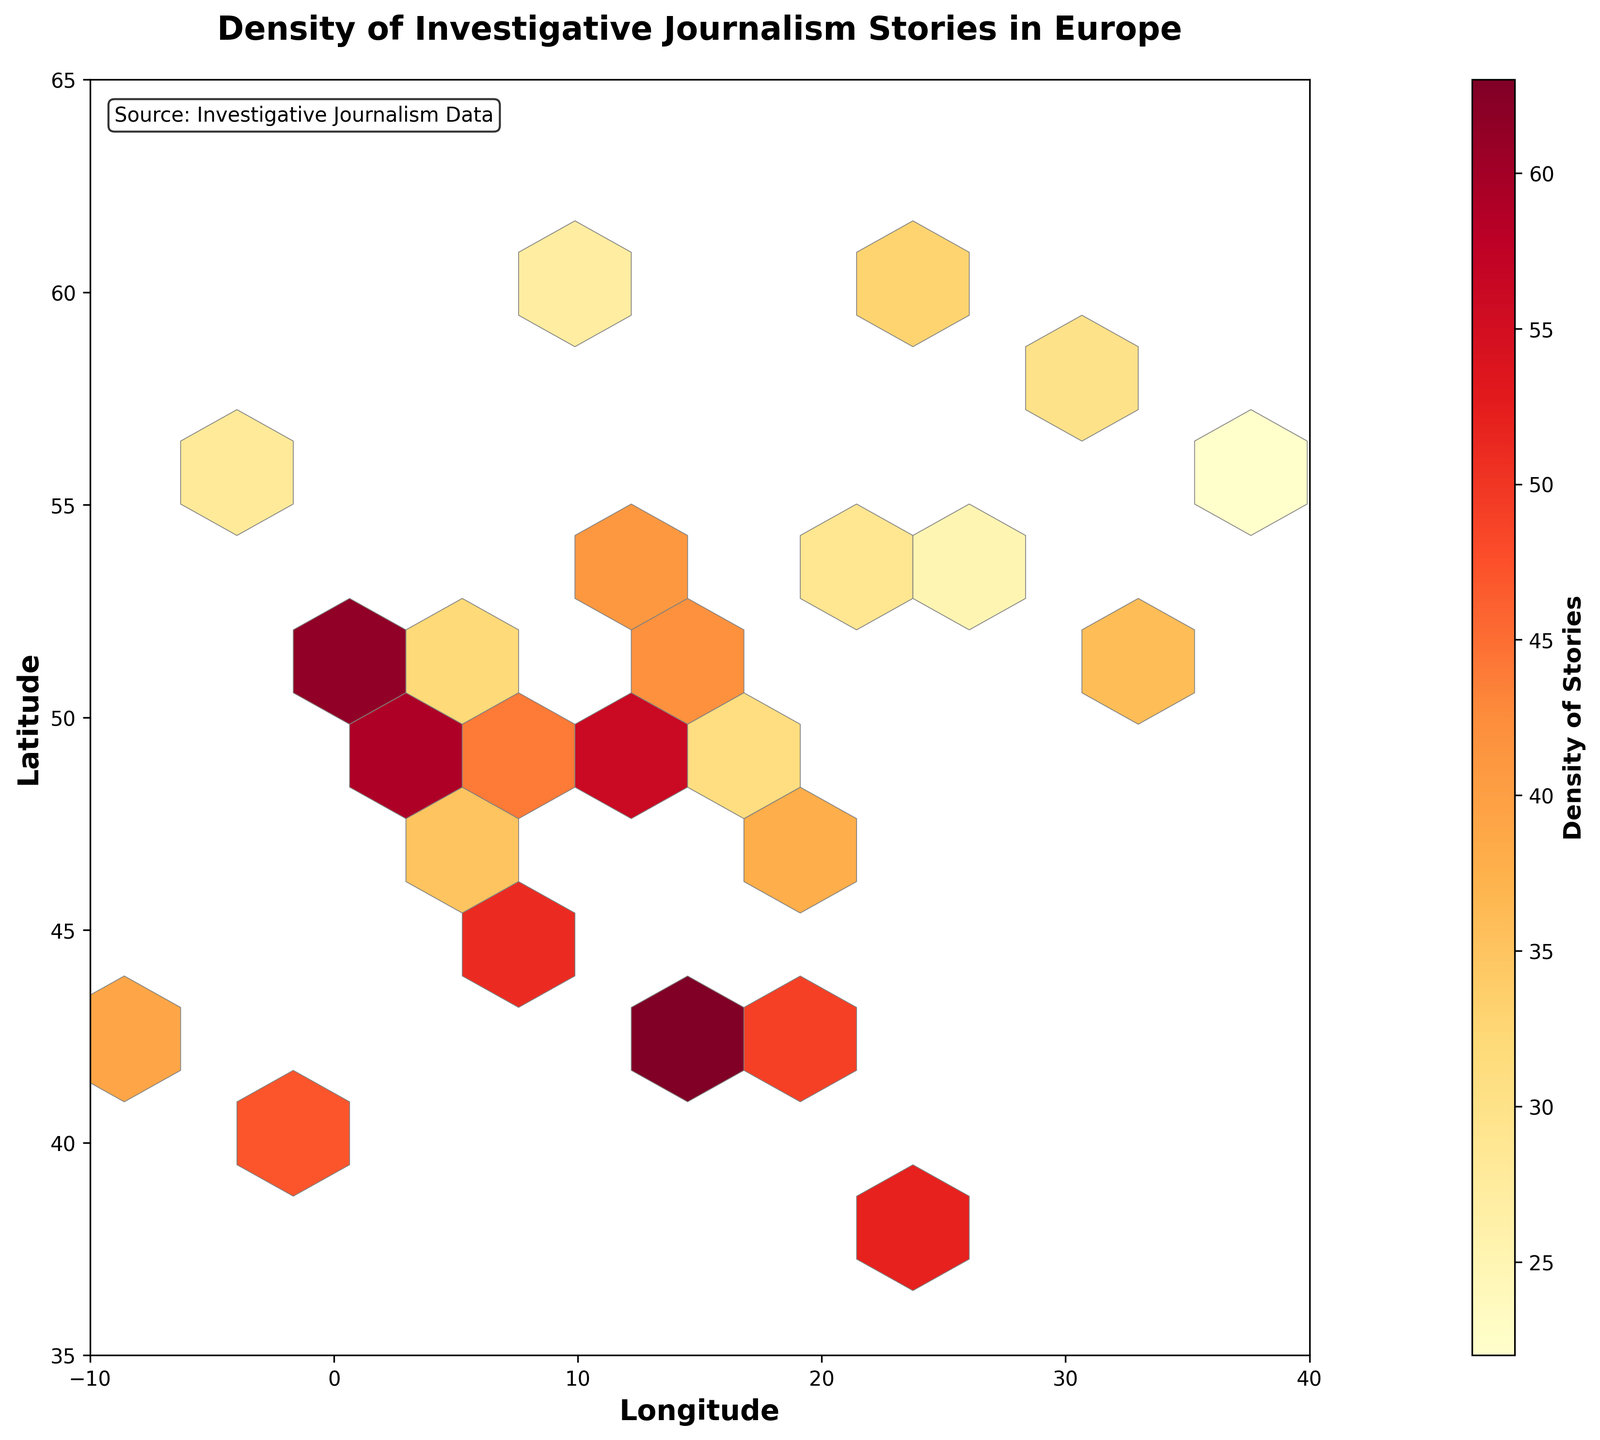What is the title of the hexbin plot? The title is clearly displayed at the top of the plot.
Answer: Density of Investigative Journalism Stories in Europe What do the axes labels represent in the figure? The x-axis represents longitude, and the y-axis represents latitude.
Answer: Longitude and Latitude What is the geographic region with the highest density of investigative journalism stories? The region around the coordinates (-0.1, 51.5) has the highest density, indicated by the darkest hexbin color.
Answer: Near (-0.1, 51.5) What is the range of longitude values shown in the plot? The x-axis spans from -10 to 40 based on the axis limits.
Answer: -10 to 40 What color represents the highest density of stories in the plot? The darkest color on the 'YlOrRd' colormap, which trends towards dark red, represents the highest density.
Answer: Dark red Which region has a density of approximately 63 stories? The region around the coordinates (12.5, 41.9) has a density of 63 stories, as indicated by the data points.
Answer: Near (12.5, 41.9) How does the density of stories near 21.0 in longitude and 52.2 in latitude compare to that near 16.4 in longitude and 48.2 in latitude? The plot shows a density of 29 stories near (21.0, 52.2) and 31 stories near (16.4, 48.2), making the density at (21.0, 52.2) slightly lower.
Answer: The density near (21.0, 52.2) is lower What is the average density of journalism stories for regions with latitude values over 50? Summing the relevant densities (78, 27, 33, 25, 36, 22, 28) and dividing by the number of data points gives approximately 35
Answer: 35 How many hexagons cover the region from longitude 10 to 20 and latitude 40 to 50? This requires visually counting the hexagons that fall within these coordinate boundaries on the plot.
Answer: 5 